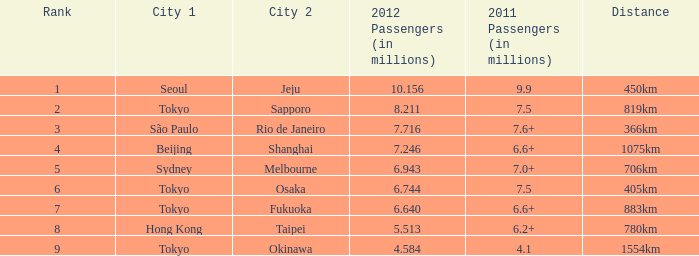In 2011, which city is listed first along the route that had 7.6+ million passengers? São Paulo. 